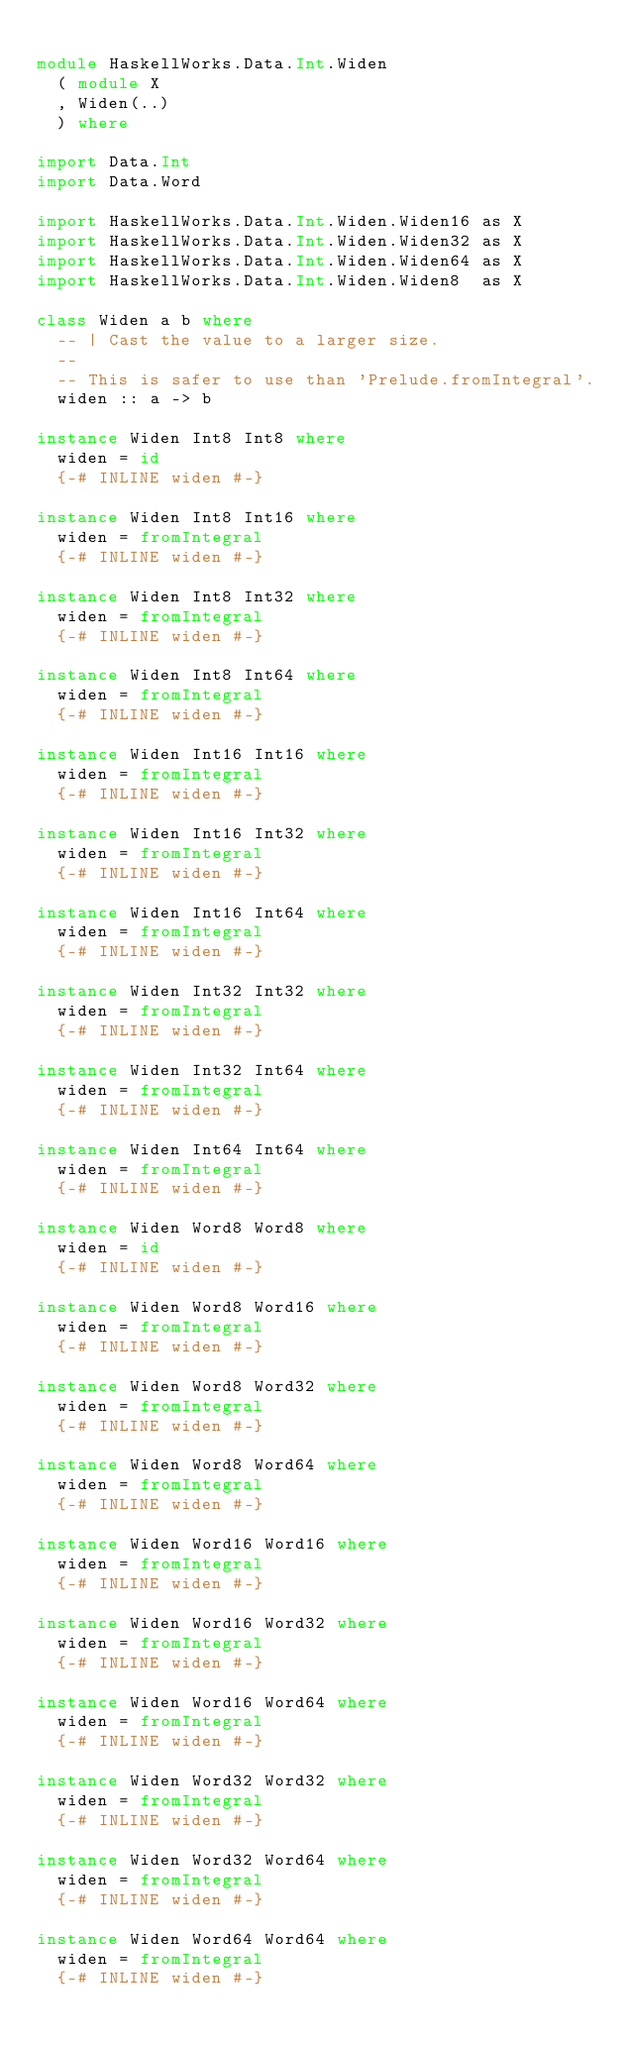Convert code to text. <code><loc_0><loc_0><loc_500><loc_500><_Haskell_>
module HaskellWorks.Data.Int.Widen
  ( module X
  , Widen(..)
  ) where

import Data.Int
import Data.Word

import HaskellWorks.Data.Int.Widen.Widen16 as X
import HaskellWorks.Data.Int.Widen.Widen32 as X
import HaskellWorks.Data.Int.Widen.Widen64 as X
import HaskellWorks.Data.Int.Widen.Widen8  as X

class Widen a b where
  -- | Cast the value to a larger size.
  --
  -- This is safer to use than 'Prelude.fromIntegral'.
  widen :: a -> b

instance Widen Int8 Int8 where
  widen = id
  {-# INLINE widen #-}

instance Widen Int8 Int16 where
  widen = fromIntegral
  {-# INLINE widen #-}

instance Widen Int8 Int32 where
  widen = fromIntegral
  {-# INLINE widen #-}

instance Widen Int8 Int64 where
  widen = fromIntegral
  {-# INLINE widen #-}

instance Widen Int16 Int16 where
  widen = fromIntegral
  {-# INLINE widen #-}

instance Widen Int16 Int32 where
  widen = fromIntegral
  {-# INLINE widen #-}

instance Widen Int16 Int64 where
  widen = fromIntegral
  {-# INLINE widen #-}

instance Widen Int32 Int32 where
  widen = fromIntegral
  {-# INLINE widen #-}

instance Widen Int32 Int64 where
  widen = fromIntegral
  {-# INLINE widen #-}

instance Widen Int64 Int64 where
  widen = fromIntegral
  {-# INLINE widen #-}

instance Widen Word8 Word8 where
  widen = id
  {-# INLINE widen #-}

instance Widen Word8 Word16 where
  widen = fromIntegral
  {-# INLINE widen #-}

instance Widen Word8 Word32 where
  widen = fromIntegral
  {-# INLINE widen #-}

instance Widen Word8 Word64 where
  widen = fromIntegral
  {-# INLINE widen #-}

instance Widen Word16 Word16 where
  widen = fromIntegral
  {-# INLINE widen #-}

instance Widen Word16 Word32 where
  widen = fromIntegral
  {-# INLINE widen #-}

instance Widen Word16 Word64 where
  widen = fromIntegral
  {-# INLINE widen #-}

instance Widen Word32 Word32 where
  widen = fromIntegral
  {-# INLINE widen #-}

instance Widen Word32 Word64 where
  widen = fromIntegral
  {-# INLINE widen #-}

instance Widen Word64 Word64 where
  widen = fromIntegral
  {-# INLINE widen #-}
</code> 